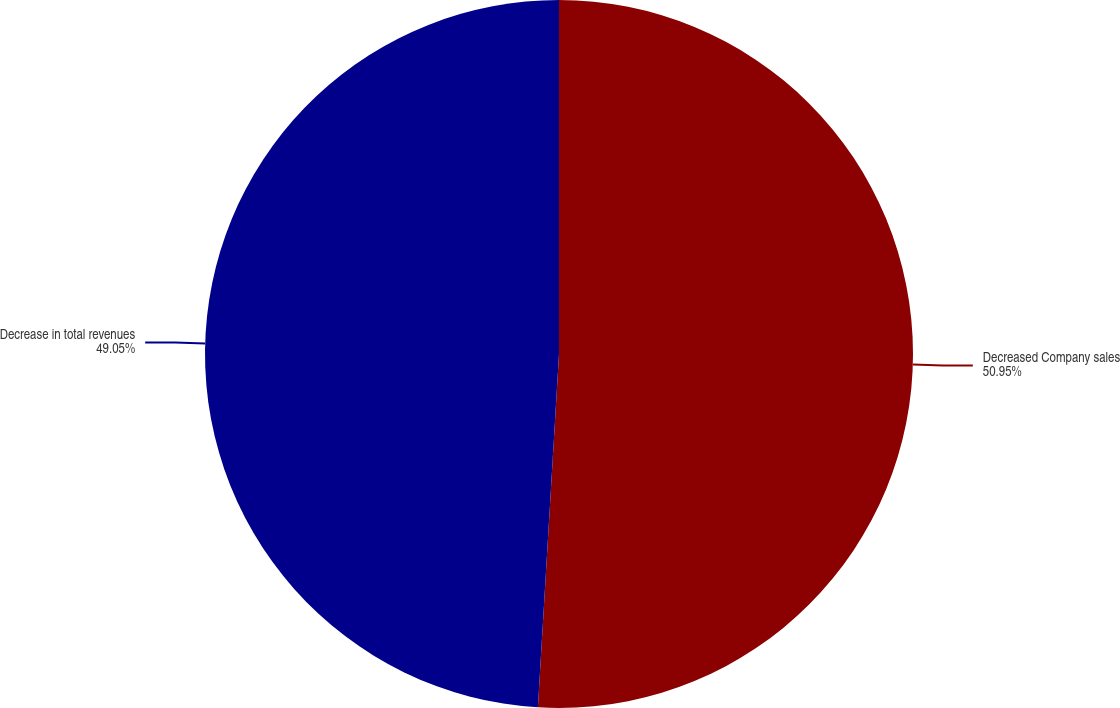Convert chart to OTSL. <chart><loc_0><loc_0><loc_500><loc_500><pie_chart><fcel>Decreased Company sales<fcel>Decrease in total revenues<nl><fcel>50.95%<fcel>49.05%<nl></chart> 